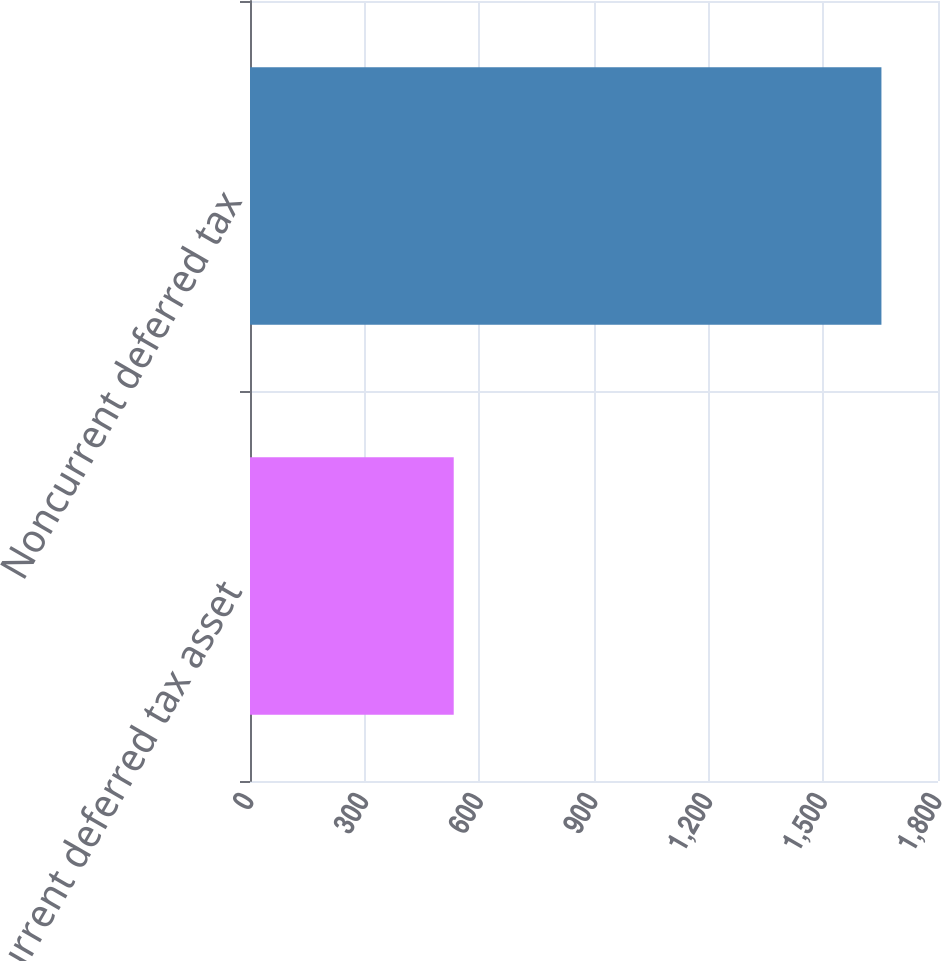<chart> <loc_0><loc_0><loc_500><loc_500><bar_chart><fcel>Current deferred tax asset<fcel>Noncurrent deferred tax<nl><fcel>533<fcel>1652<nl></chart> 